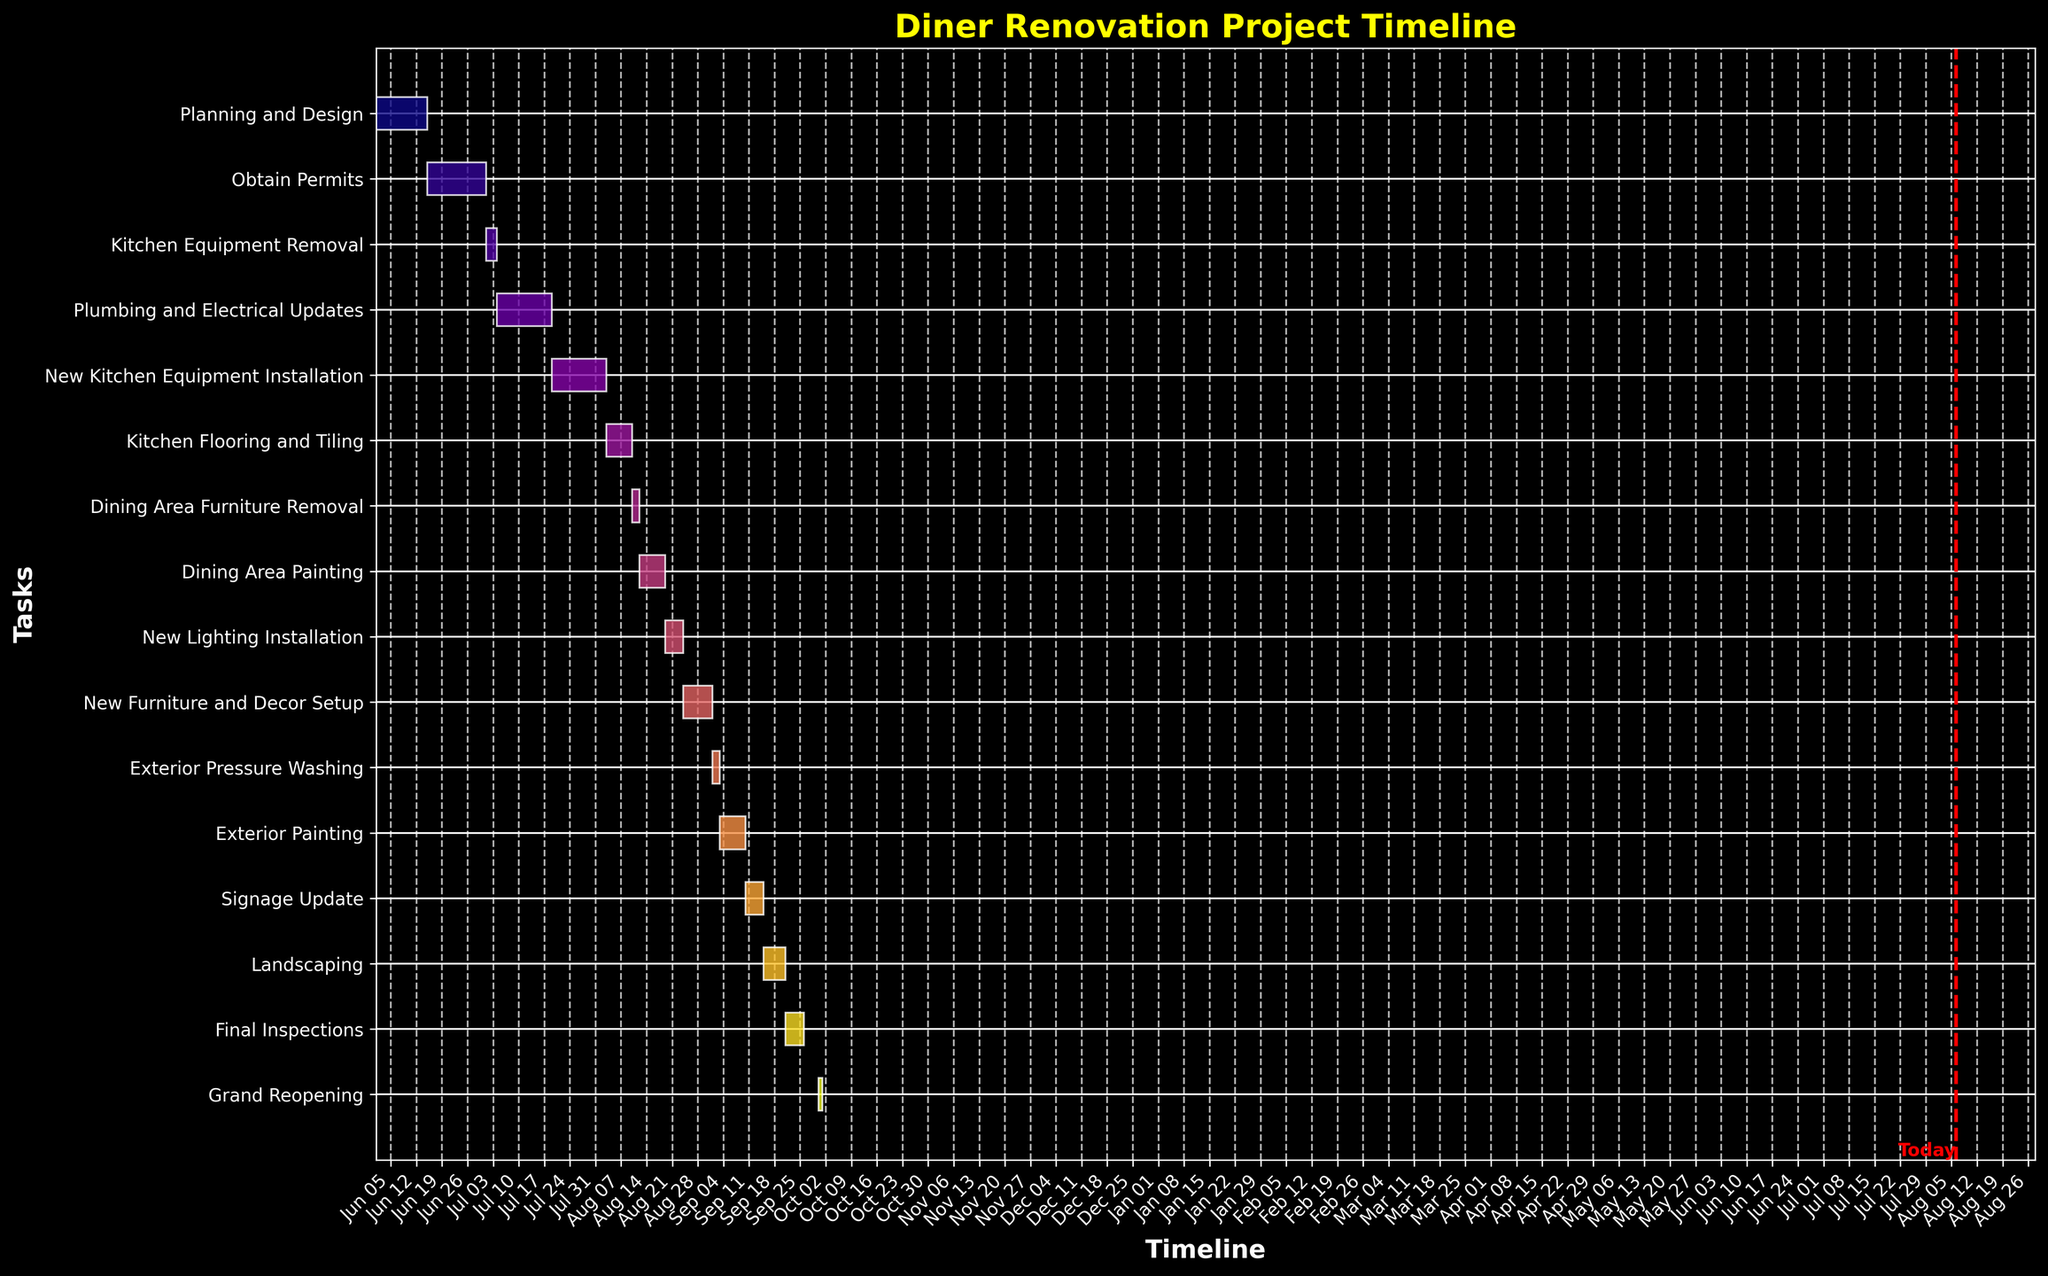What is the title of the chart? The title is usually displayed prominently at the top of the chart. Reading this, you can identify the overall topic of the Gantt Chart.
Answer: Diner Renovation Project Timeline How many tasks are shown on the Gantt Chart? By counting the number of horizontal bars on the chart, you can determine the number of tasks.
Answer: 16 When is the Grand Reopening scheduled? Locate the "Grand Reopening" task on the vertical axis and read the corresponding date from the horizontal axis.
Answer: September 30, 2023 Which task has the longest duration? Measure the length of each horizontal bar visually, and identify the one that spans the most days between the start and end date.
Answer: Obtain Permits What is the total time span for the entire renovation project from start to finish? Identify the start date of the first task and the end date of the last task, then calculate the difference between the two dates.
Answer: June 1, 2023 to September 30, 2023 During which dates will the dining area painting take place, and how long will it last? Locate the "Dining Area Painting" task on the vertical axis, and trace horizontally to check the start and end dates, then calculate the number of days between them.
Answer: August 12, 2023 to August 18, 2023, lasting 7 days Which tasks are scheduled to start in July? Scan the timeline to identify tasks starting in July by checking their start dates and listing them accordingly.
Answer: Kitchen Equipment Removal, Plumbing and Electrical Updates, New Kitchen Equipment Installation What tasks are dependent on the completion of the 'New Kitchen Equipment Installation'? Identify which tasks start immediately after the end of 'New Kitchen Equipment Installation' by checking the tasks' dates visually.
Answer: Kitchen Flooring and Tiling Which tasks are overlapping in their duration? Observe the horizontal bars to see which ones visually overlap with others in the timeline. You can list these tasks.
Answer: New Kitchen Equipment Installation and Kitchen Flooring and Tiling How many tasks fall under exterior improvements? Identify all tasks related to exterior improvements by their names and count them.
Answer: 4 